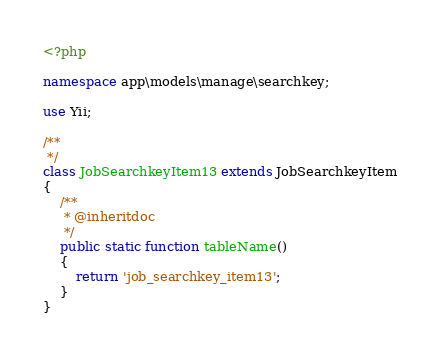Convert code to text. <code><loc_0><loc_0><loc_500><loc_500><_PHP_><?php

namespace app\models\manage\searchkey;

use Yii;

/**
 */
class JobSearchkeyItem13 extends JobSearchkeyItem
{
    /**
     * @inheritdoc
     */
    public static function tableName()
    {
        return 'job_searchkey_item13';
    }
}
</code> 